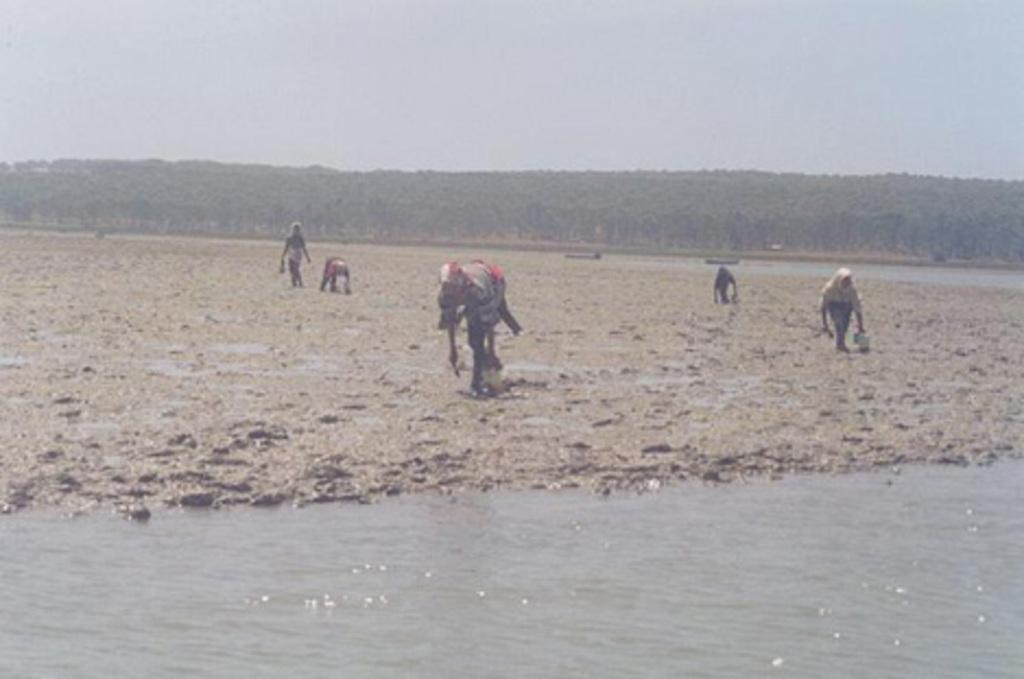What is happening in the image? There are people standing in the image. What is in front of the people? There is a river in front of the people. What can be seen in the background of the image? There are trees and the sky visible in the background of the image. How many rings are being thrown in the image? There are no rings present in the image; it features people standing near a river with trees and sky in the background. 